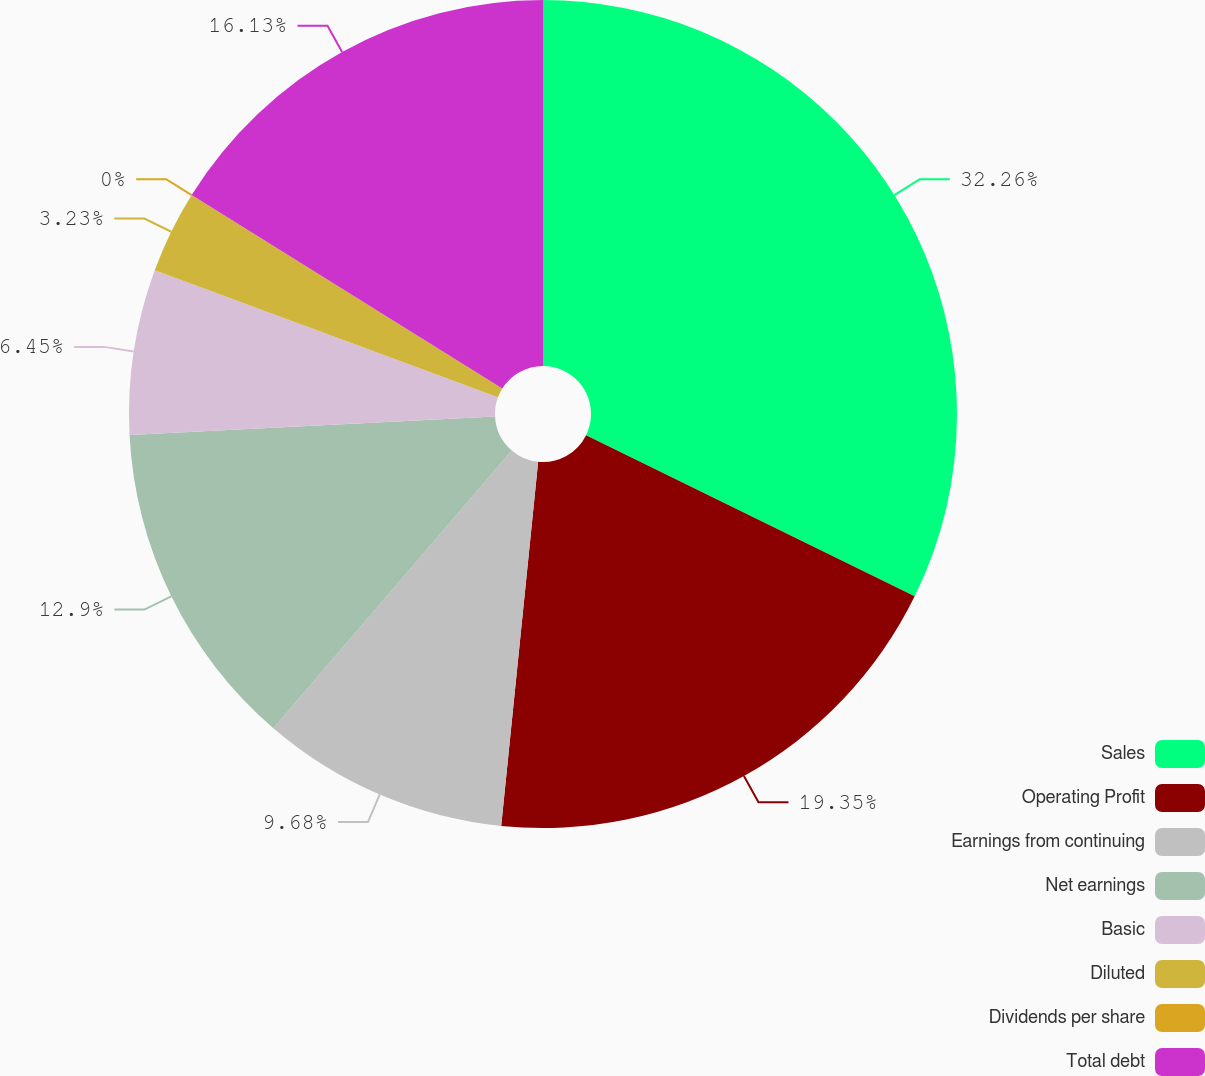Convert chart. <chart><loc_0><loc_0><loc_500><loc_500><pie_chart><fcel>Sales<fcel>Operating Profit<fcel>Earnings from continuing<fcel>Net earnings<fcel>Basic<fcel>Diluted<fcel>Dividends per share<fcel>Total debt<nl><fcel>32.26%<fcel>19.35%<fcel>9.68%<fcel>12.9%<fcel>6.45%<fcel>3.23%<fcel>0.0%<fcel>16.13%<nl></chart> 